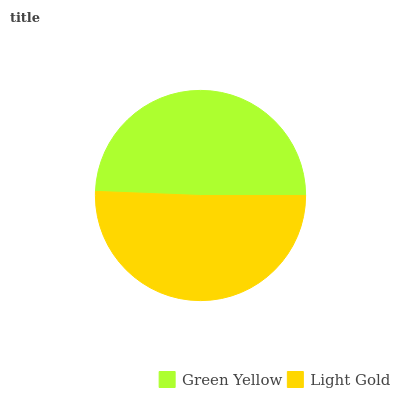Is Green Yellow the minimum?
Answer yes or no. Yes. Is Light Gold the maximum?
Answer yes or no. Yes. Is Light Gold the minimum?
Answer yes or no. No. Is Light Gold greater than Green Yellow?
Answer yes or no. Yes. Is Green Yellow less than Light Gold?
Answer yes or no. Yes. Is Green Yellow greater than Light Gold?
Answer yes or no. No. Is Light Gold less than Green Yellow?
Answer yes or no. No. Is Light Gold the high median?
Answer yes or no. Yes. Is Green Yellow the low median?
Answer yes or no. Yes. Is Green Yellow the high median?
Answer yes or no. No. Is Light Gold the low median?
Answer yes or no. No. 